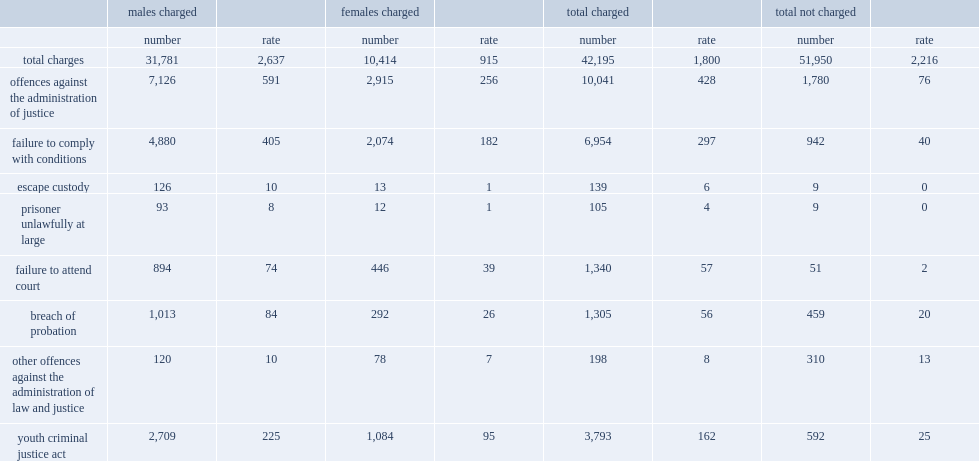Among youth accused of offences against the administration of justice in 2014, what is the percentage of charges were subjected to formal charges instead of extrajudicial measures? 0.849421. 